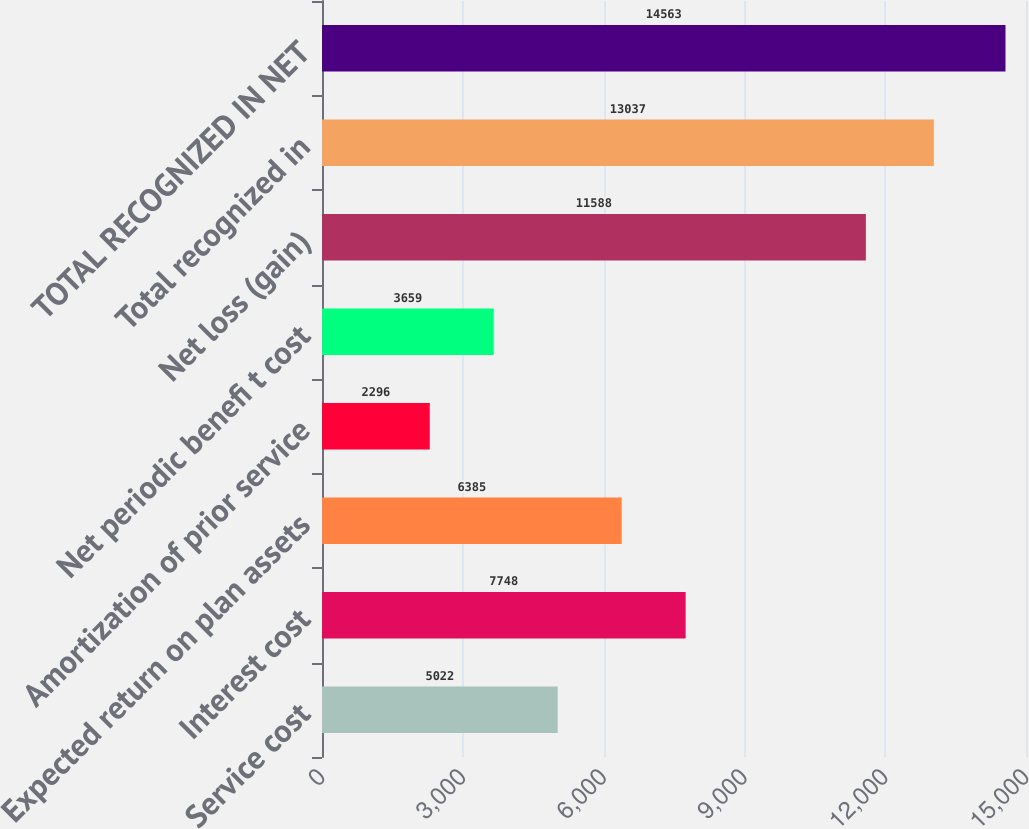<chart> <loc_0><loc_0><loc_500><loc_500><bar_chart><fcel>Service cost<fcel>Interest cost<fcel>Expected return on plan assets<fcel>Amortization of prior service<fcel>Net periodic benefi t cost<fcel>Net loss (gain)<fcel>Total recognized in<fcel>TOTAL RECOGNIZED IN NET<nl><fcel>5022<fcel>7748<fcel>6385<fcel>2296<fcel>3659<fcel>11588<fcel>13037<fcel>14563<nl></chart> 